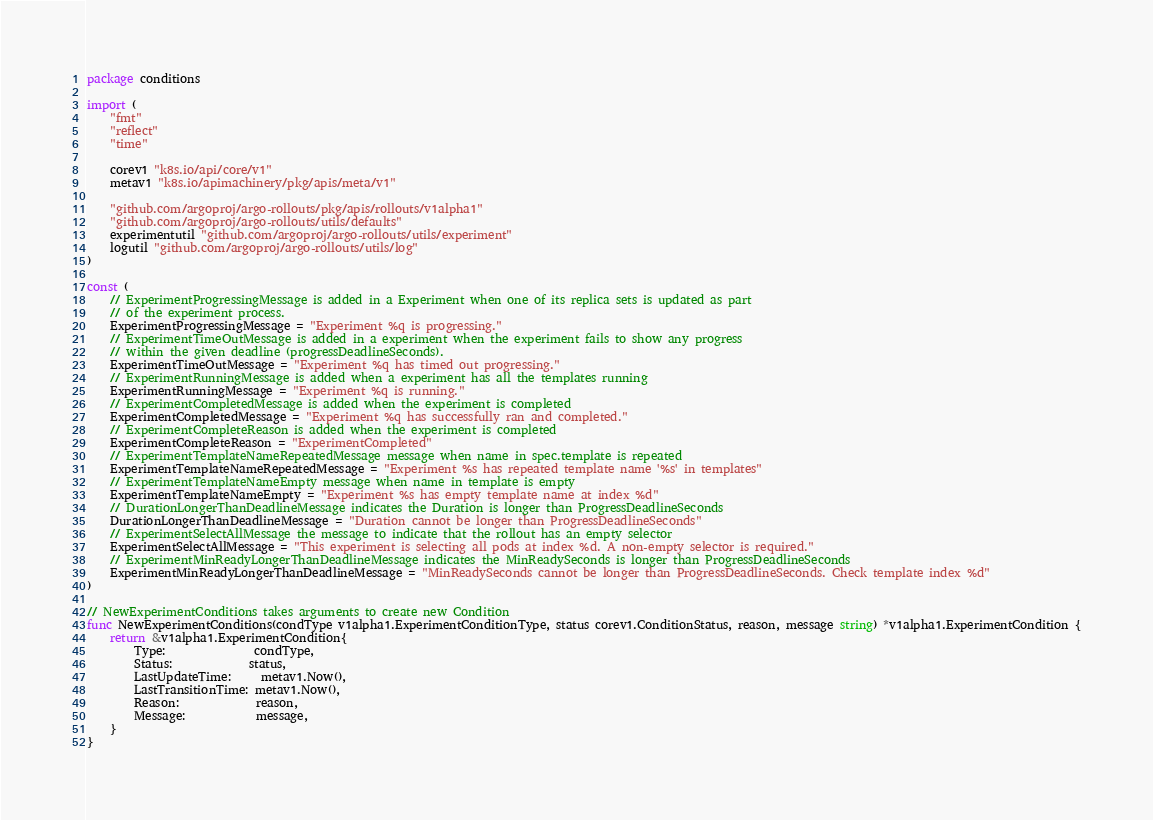Convert code to text. <code><loc_0><loc_0><loc_500><loc_500><_Go_>package conditions

import (
	"fmt"
	"reflect"
	"time"

	corev1 "k8s.io/api/core/v1"
	metav1 "k8s.io/apimachinery/pkg/apis/meta/v1"

	"github.com/argoproj/argo-rollouts/pkg/apis/rollouts/v1alpha1"
	"github.com/argoproj/argo-rollouts/utils/defaults"
	experimentutil "github.com/argoproj/argo-rollouts/utils/experiment"
	logutil "github.com/argoproj/argo-rollouts/utils/log"
)

const (
	// ExperimentProgressingMessage is added in a Experiment when one of its replica sets is updated as part
	// of the experiment process.
	ExperimentProgressingMessage = "Experiment %q is progressing."
	// ExperimentTimeOutMessage is added in a experiment when the experiment fails to show any progress
	// within the given deadline (progressDeadlineSeconds).
	ExperimentTimeOutMessage = "Experiment %q has timed out progressing."
	// ExperimentRunningMessage is added when a experiment has all the templates running
	ExperimentRunningMessage = "Experiment %q is running."
	// ExperimentCompletedMessage is added when the experiment is completed
	ExperimentCompletedMessage = "Experiment %q has successfully ran and completed."
	// ExperimentCompleteReason is added when the experiment is completed
	ExperimentCompleteReason = "ExperimentCompleted"
	// ExperimentTemplateNameRepeatedMessage message when name in spec.template is repeated
	ExperimentTemplateNameRepeatedMessage = "Experiment %s has repeated template name '%s' in templates"
	// ExperimentTemplateNameEmpty message when name in template is empty
	ExperimentTemplateNameEmpty = "Experiment %s has empty template name at index %d"
	// DurationLongerThanDeadlineMessage indicates the Duration is longer than ProgressDeadlineSeconds
	DurationLongerThanDeadlineMessage = "Duration cannot be longer than ProgressDeadlineSeconds"
	// ExperimentSelectAllMessage the message to indicate that the rollout has an empty selector
	ExperimentSelectAllMessage = "This experiment is selecting all pods at index %d. A non-empty selector is required."
	// ExperimentMinReadyLongerThanDeadlineMessage indicates the MinReadySeconds is longer than ProgressDeadlineSeconds
	ExperimentMinReadyLongerThanDeadlineMessage = "MinReadySeconds cannot be longer than ProgressDeadlineSeconds. Check template index %d"
)

// NewExperimentConditions takes arguments to create new Condition
func NewExperimentConditions(condType v1alpha1.ExperimentConditionType, status corev1.ConditionStatus, reason, message string) *v1alpha1.ExperimentCondition {
	return &v1alpha1.ExperimentCondition{
		Type:               condType,
		Status:             status,
		LastUpdateTime:     metav1.Now(),
		LastTransitionTime: metav1.Now(),
		Reason:             reason,
		Message:            message,
	}
}
</code> 